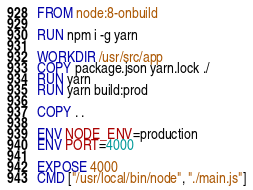<code> <loc_0><loc_0><loc_500><loc_500><_Dockerfile_>FROM node:8-onbuild

RUN npm i -g yarn

WORKDIR /usr/src/app
COPY package.json yarn.lock ./
RUN yarn
RUN yarn build:prod

COPY . .

ENV NODE_ENV=production
ENV PORT=4000

EXPOSE 4000
CMD ["/usr/local/bin/node", "./main.js"]</code> 